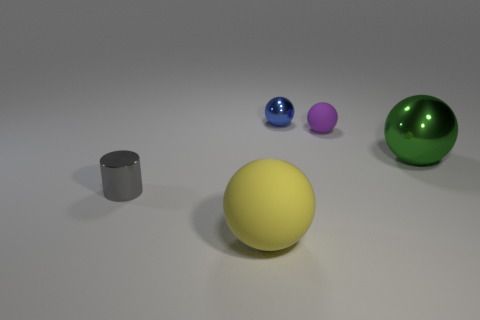Add 3 shiny spheres. How many objects exist? 8 Subtract all large green balls. How many balls are left? 3 Subtract all blue spheres. How many spheres are left? 3 Subtract all yellow cylinders. How many red spheres are left? 0 Subtract all green cubes. Subtract all yellow spheres. How many objects are left? 4 Add 4 big spheres. How many big spheres are left? 6 Add 1 tiny rubber spheres. How many tiny rubber spheres exist? 2 Subtract 0 green cylinders. How many objects are left? 5 Subtract all spheres. How many objects are left? 1 Subtract 1 cylinders. How many cylinders are left? 0 